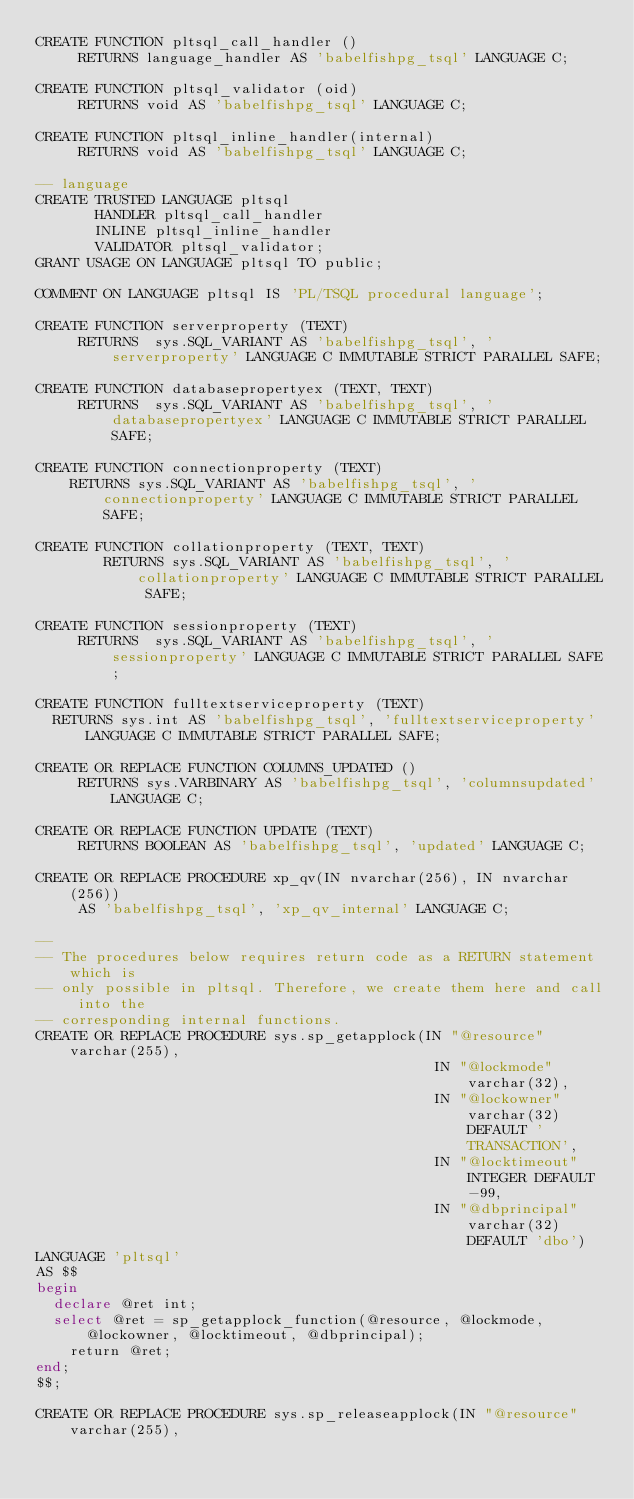<code> <loc_0><loc_0><loc_500><loc_500><_SQL_>CREATE FUNCTION pltsql_call_handler ()
	   RETURNS language_handler AS 'babelfishpg_tsql' LANGUAGE C;

CREATE FUNCTION pltsql_validator (oid)
	   RETURNS void AS 'babelfishpg_tsql' LANGUAGE C;

CREATE FUNCTION pltsql_inline_handler(internal)
	   RETURNS void AS 'babelfishpg_tsql' LANGUAGE C;

-- language
CREATE TRUSTED LANGUAGE pltsql
       HANDLER pltsql_call_handler
       INLINE pltsql_inline_handler
       VALIDATOR pltsql_validator;
GRANT USAGE ON LANGUAGE pltsql TO public;

COMMENT ON LANGUAGE pltsql IS 'PL/TSQL procedural language';

CREATE FUNCTION serverproperty (TEXT)
	   RETURNS  sys.SQL_VARIANT AS 'babelfishpg_tsql', 'serverproperty' LANGUAGE C IMMUTABLE STRICT PARALLEL SAFE;

CREATE FUNCTION databasepropertyex (TEXT, TEXT)
	   RETURNS  sys.SQL_VARIANT AS 'babelfishpg_tsql', 'databasepropertyex' LANGUAGE C IMMUTABLE STRICT PARALLEL SAFE;

CREATE FUNCTION connectionproperty (TEXT)
		RETURNS sys.SQL_VARIANT AS 'babelfishpg_tsql', 'connectionproperty' LANGUAGE C IMMUTABLE STRICT PARALLEL SAFE;

CREATE FUNCTION collationproperty (TEXT, TEXT)
        RETURNS sys.SQL_VARIANT AS 'babelfishpg_tsql', 'collationproperty' LANGUAGE C IMMUTABLE STRICT PARALLEL SAFE;

CREATE FUNCTION sessionproperty (TEXT)
	   RETURNS  sys.SQL_VARIANT AS 'babelfishpg_tsql', 'sessionproperty' LANGUAGE C IMMUTABLE STRICT PARALLEL SAFE;

CREATE FUNCTION fulltextserviceproperty (TEXT)
	RETURNS sys.int AS 'babelfishpg_tsql', 'fulltextserviceproperty' LANGUAGE C IMMUTABLE STRICT PARALLEL SAFE;

CREATE OR REPLACE FUNCTION COLUMNS_UPDATED ()
	   RETURNS sys.VARBINARY AS 'babelfishpg_tsql', 'columnsupdated' LANGUAGE C;

CREATE OR REPLACE FUNCTION UPDATE (TEXT)
	   RETURNS BOOLEAN AS 'babelfishpg_tsql', 'updated' LANGUAGE C;

CREATE OR REPLACE PROCEDURE xp_qv(IN nvarchar(256), IN nvarchar(256))
	   AS 'babelfishpg_tsql', 'xp_qv_internal' LANGUAGE C;

--
-- The procedures below requires return code as a RETURN statement which is
-- only possible in pltsql. Therefore, we create them here and call into the
-- corresponding internal functions.
CREATE OR REPLACE PROCEDURE sys.sp_getapplock(IN "@resource" varchar(255),
                                               IN "@lockmode" varchar(32),
                                               IN "@lockowner" varchar(32) DEFAULT 'TRANSACTION',
                                               IN "@locktimeout" INTEGER DEFAULT -99,
                                               IN "@dbprincipal" varchar(32) DEFAULT 'dbo')
LANGUAGE 'pltsql'
AS $$
begin
	declare @ret int;
	select @ret = sp_getapplock_function(@resource, @lockmode, @lockowner, @locktimeout, @dbprincipal);
    return @ret;
end;
$$;

CREATE OR REPLACE PROCEDURE sys.sp_releaseapplock(IN "@resource" varchar(255),</code> 